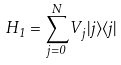Convert formula to latex. <formula><loc_0><loc_0><loc_500><loc_500>H _ { 1 } = \sum _ { j = 0 } ^ { N } V _ { j } | j \rangle \langle j |</formula> 